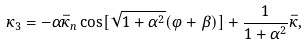Convert formula to latex. <formula><loc_0><loc_0><loc_500><loc_500>\kappa _ { 3 } = - \alpha \bar { \kappa } _ { n } \cos [ \sqrt { 1 + \alpha ^ { 2 } } ( \varphi + \beta ) ] + \frac { 1 } { 1 + \alpha ^ { 2 } } \bar { \kappa } ,</formula> 